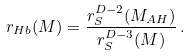Convert formula to latex. <formula><loc_0><loc_0><loc_500><loc_500>r _ { H b } ( M ) = \frac { r _ { S } ^ { D - 2 } ( M _ { A H } ) } { r _ { S } ^ { D - 3 } ( M ) } \, .</formula> 